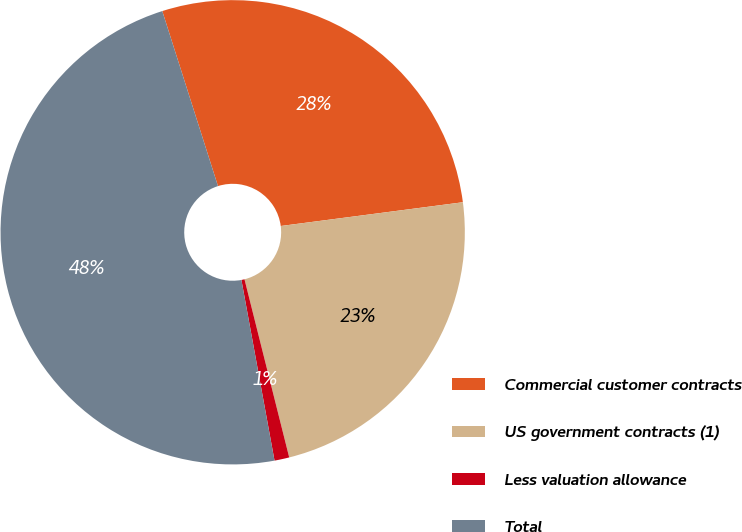<chart> <loc_0><loc_0><loc_500><loc_500><pie_chart><fcel>Commercial customer contracts<fcel>US government contracts (1)<fcel>Less valuation allowance<fcel>Total<nl><fcel>27.84%<fcel>23.15%<fcel>1.03%<fcel>47.98%<nl></chart> 